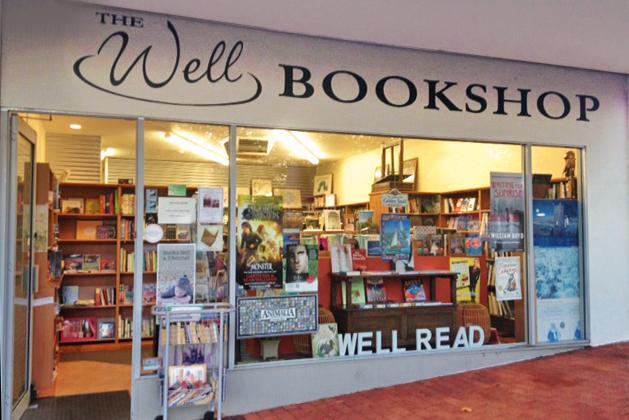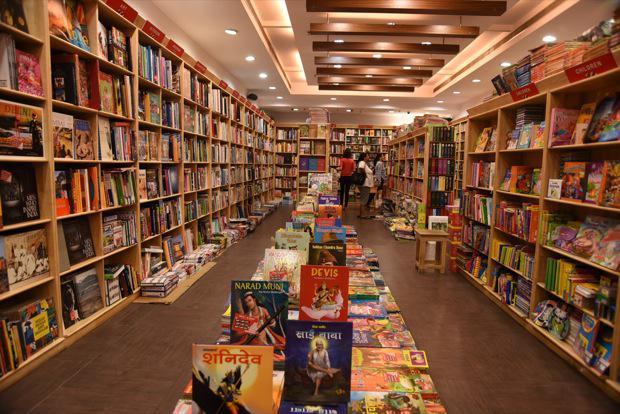The first image is the image on the left, the second image is the image on the right. For the images shown, is this caption "There is at least one person in the image on the left." true? Answer yes or no. No. 